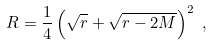Convert formula to latex. <formula><loc_0><loc_0><loc_500><loc_500>R = \frac { 1 } { 4 } \left ( \sqrt { r } + \sqrt { r - 2 M } \right ) ^ { 2 } \ ,</formula> 